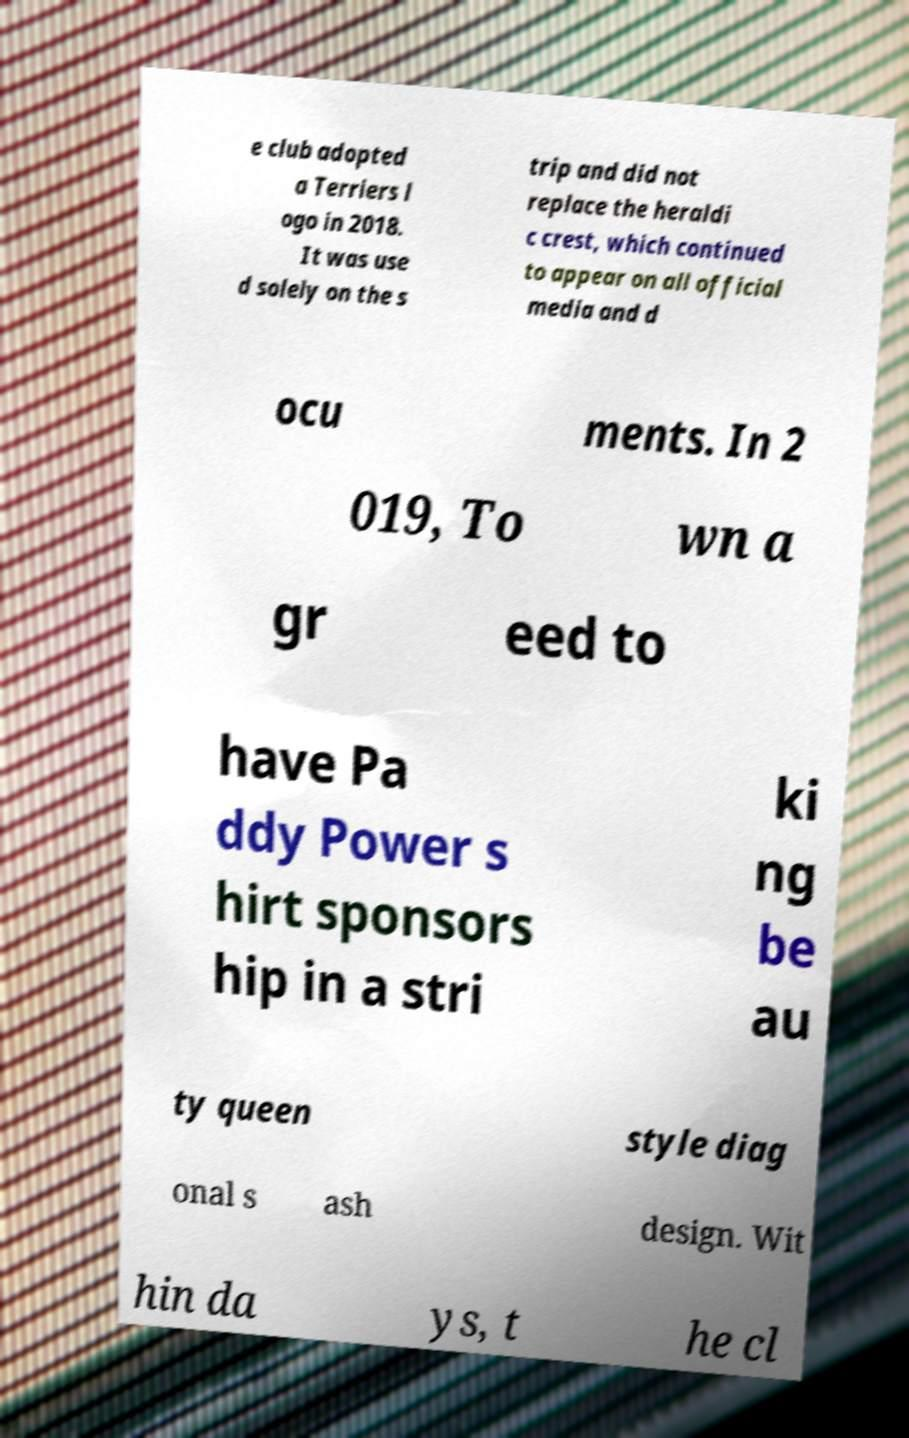Please identify and transcribe the text found in this image. e club adopted a Terriers l ogo in 2018. It was use d solely on the s trip and did not replace the heraldi c crest, which continued to appear on all official media and d ocu ments. In 2 019, To wn a gr eed to have Pa ddy Power s hirt sponsors hip in a stri ki ng be au ty queen style diag onal s ash design. Wit hin da ys, t he cl 